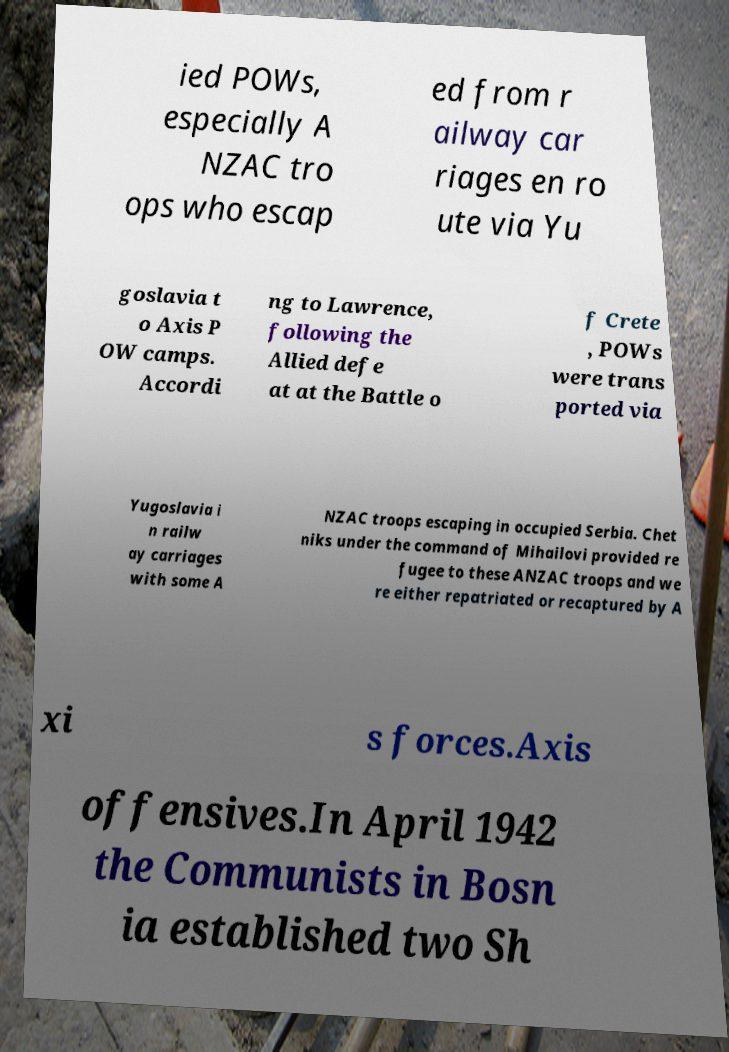I need the written content from this picture converted into text. Can you do that? ied POWs, especially A NZAC tro ops who escap ed from r ailway car riages en ro ute via Yu goslavia t o Axis P OW camps. Accordi ng to Lawrence, following the Allied defe at at the Battle o f Crete , POWs were trans ported via Yugoslavia i n railw ay carriages with some A NZAC troops escaping in occupied Serbia. Chet niks under the command of Mihailovi provided re fugee to these ANZAC troops and we re either repatriated or recaptured by A xi s forces.Axis offensives.In April 1942 the Communists in Bosn ia established two Sh 